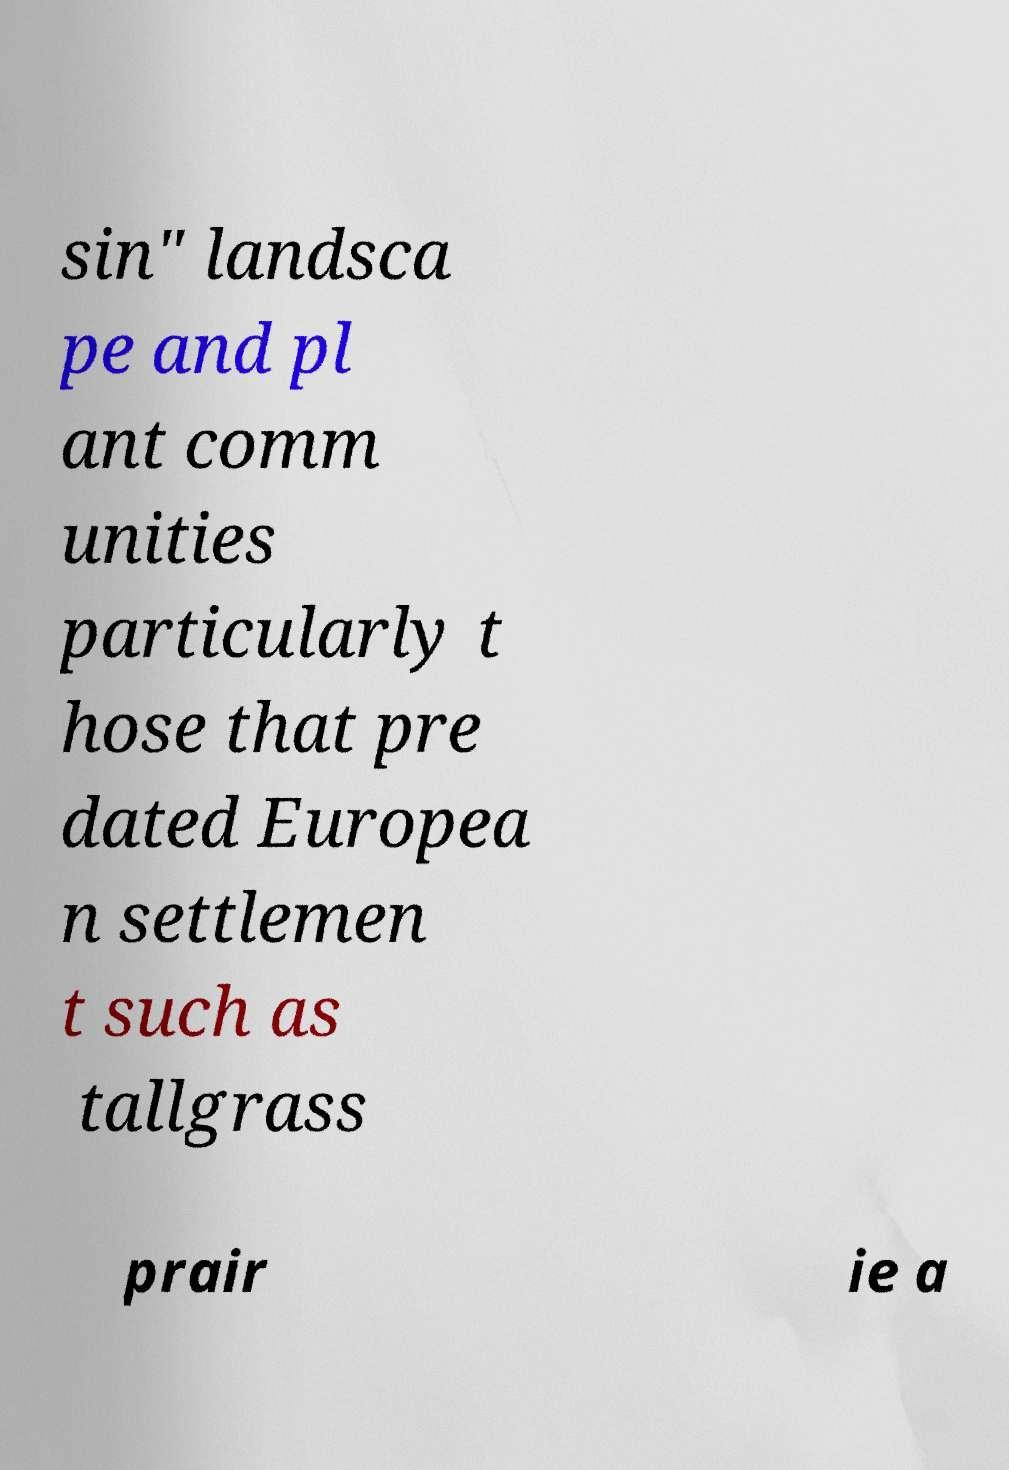I need the written content from this picture converted into text. Can you do that? sin" landsca pe and pl ant comm unities particularly t hose that pre dated Europea n settlemen t such as tallgrass prair ie a 